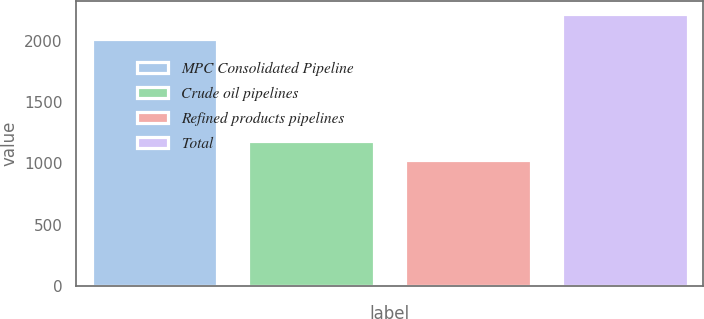<chart> <loc_0><loc_0><loc_500><loc_500><bar_chart><fcel>MPC Consolidated Pipeline<fcel>Crude oil pipelines<fcel>Refined products pipelines<fcel>Total<nl><fcel>2011<fcel>1184<fcel>1031<fcel>2215<nl></chart> 